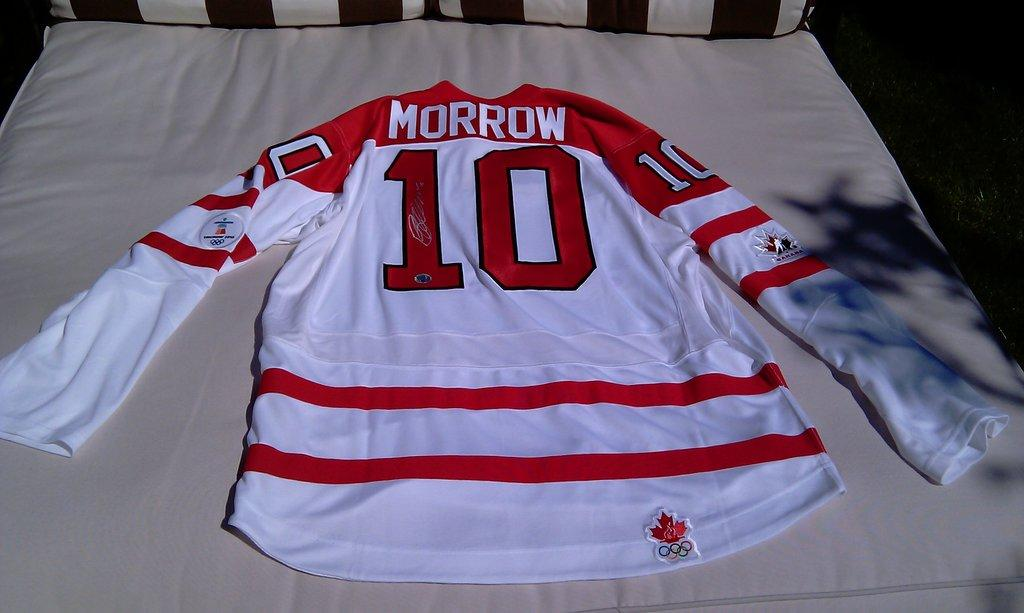<image>
Provide a brief description of the given image. A red and white hockey jersey for someone named Morrow. 